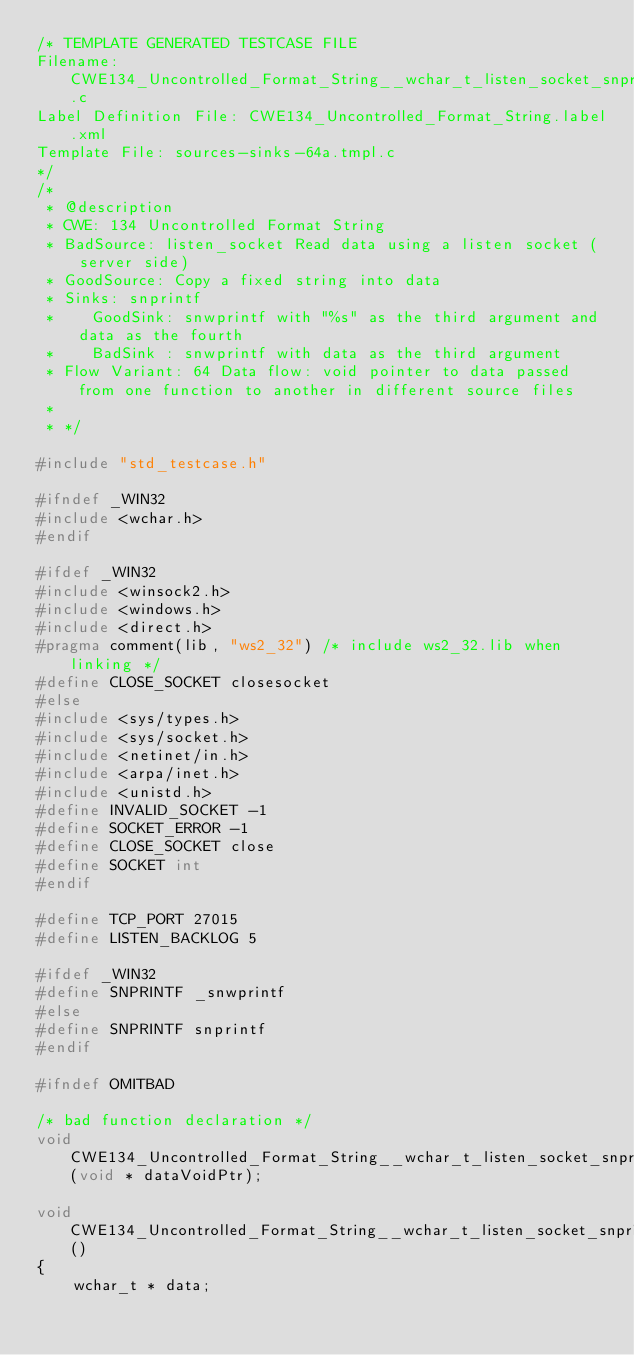<code> <loc_0><loc_0><loc_500><loc_500><_C_>/* TEMPLATE GENERATED TESTCASE FILE
Filename: CWE134_Uncontrolled_Format_String__wchar_t_listen_socket_snprintf_64a.c
Label Definition File: CWE134_Uncontrolled_Format_String.label.xml
Template File: sources-sinks-64a.tmpl.c
*/
/*
 * @description
 * CWE: 134 Uncontrolled Format String
 * BadSource: listen_socket Read data using a listen socket (server side)
 * GoodSource: Copy a fixed string into data
 * Sinks: snprintf
 *    GoodSink: snwprintf with "%s" as the third argument and data as the fourth
 *    BadSink : snwprintf with data as the third argument
 * Flow Variant: 64 Data flow: void pointer to data passed from one function to another in different source files
 *
 * */

#include "std_testcase.h"

#ifndef _WIN32
#include <wchar.h>
#endif

#ifdef _WIN32
#include <winsock2.h>
#include <windows.h>
#include <direct.h>
#pragma comment(lib, "ws2_32") /* include ws2_32.lib when linking */
#define CLOSE_SOCKET closesocket
#else
#include <sys/types.h>
#include <sys/socket.h>
#include <netinet/in.h>
#include <arpa/inet.h>
#include <unistd.h>
#define INVALID_SOCKET -1
#define SOCKET_ERROR -1
#define CLOSE_SOCKET close
#define SOCKET int
#endif

#define TCP_PORT 27015
#define LISTEN_BACKLOG 5

#ifdef _WIN32
#define SNPRINTF _snwprintf
#else
#define SNPRINTF snprintf
#endif

#ifndef OMITBAD

/* bad function declaration */
void CWE134_Uncontrolled_Format_String__wchar_t_listen_socket_snprintf_64b_badSink(void * dataVoidPtr);

void CWE134_Uncontrolled_Format_String__wchar_t_listen_socket_snprintf_64_bad()
{
    wchar_t * data;</code> 